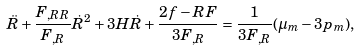Convert formula to latex. <formula><loc_0><loc_0><loc_500><loc_500>\ddot { R } + \frac { F _ { , R R } } { F _ { , R } } \dot { R } ^ { 2 } + 3 H \dot { R } + \frac { 2 f - R F } { 3 F _ { , R } } = \frac { 1 } { 3 F _ { , R } } ( \mu _ { m } - 3 p _ { m } ) ,</formula> 